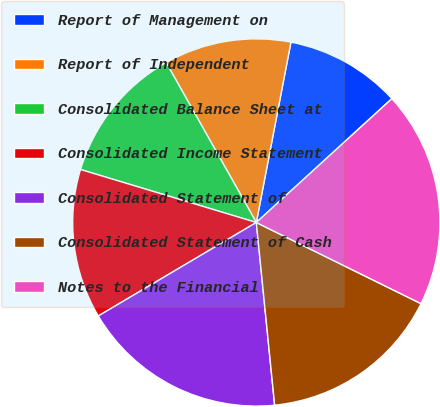<chart> <loc_0><loc_0><loc_500><loc_500><pie_chart><fcel>Report of Management on<fcel>Report of Independent<fcel>Consolidated Balance Sheet at<fcel>Consolidated Income Statement<fcel>Consolidated Statement of<fcel>Consolidated Statement of Cash<fcel>Notes to the Financial<nl><fcel>10.2%<fcel>11.19%<fcel>12.17%<fcel>13.16%<fcel>18.09%<fcel>16.12%<fcel>19.07%<nl></chart> 